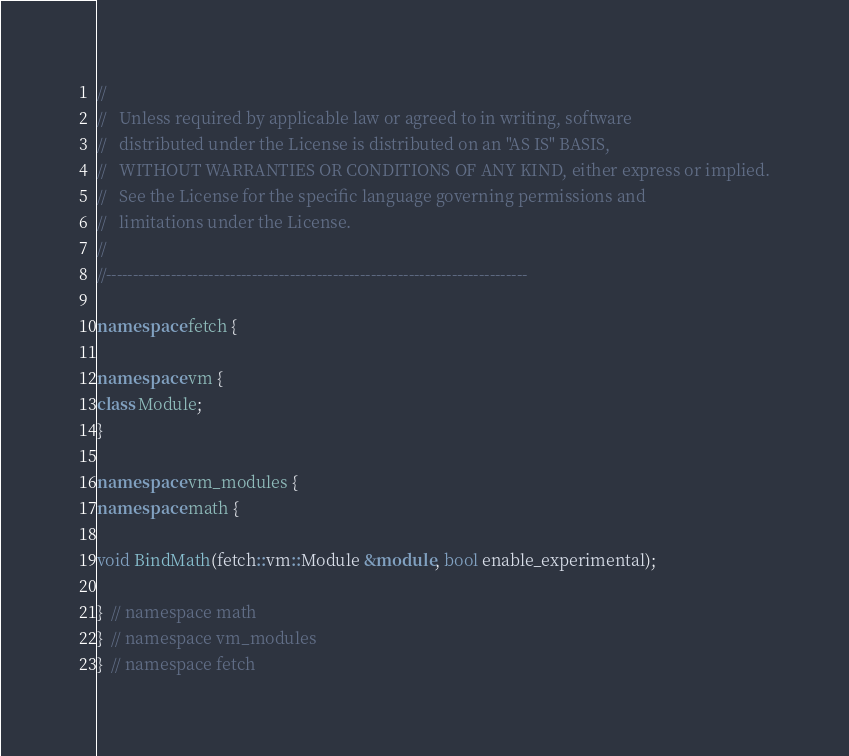<code> <loc_0><loc_0><loc_500><loc_500><_C++_>//
//   Unless required by applicable law or agreed to in writing, software
//   distributed under the License is distributed on an "AS IS" BASIS,
//   WITHOUT WARRANTIES OR CONDITIONS OF ANY KIND, either express or implied.
//   See the License for the specific language governing permissions and
//   limitations under the License.
//
//------------------------------------------------------------------------------

namespace fetch {

namespace vm {
class Module;
}

namespace vm_modules {
namespace math {

void BindMath(fetch::vm::Module &module, bool enable_experimental);

}  // namespace math
}  // namespace vm_modules
}  // namespace fetch
</code> 